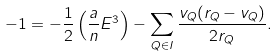Convert formula to latex. <formula><loc_0><loc_0><loc_500><loc_500>- 1 = - \frac { 1 } { 2 } \left ( \frac { a } { n } E ^ { 3 } \right ) - \sum _ { Q \in I } \frac { v _ { Q } ( r _ { Q } - v _ { Q } ) } { 2 r _ { Q } } .</formula> 